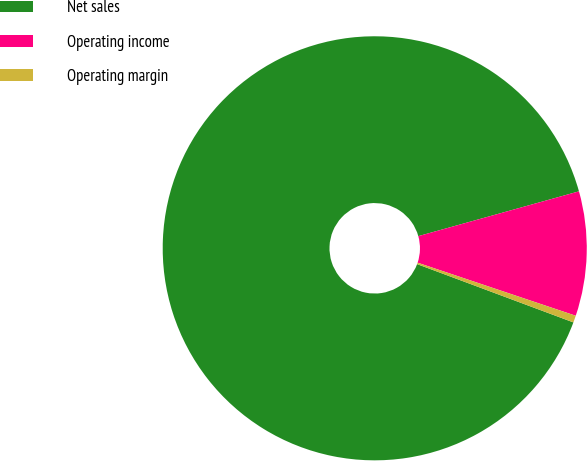Convert chart to OTSL. <chart><loc_0><loc_0><loc_500><loc_500><pie_chart><fcel>Net sales<fcel>Operating income<fcel>Operating margin<nl><fcel>89.99%<fcel>9.48%<fcel>0.53%<nl></chart> 